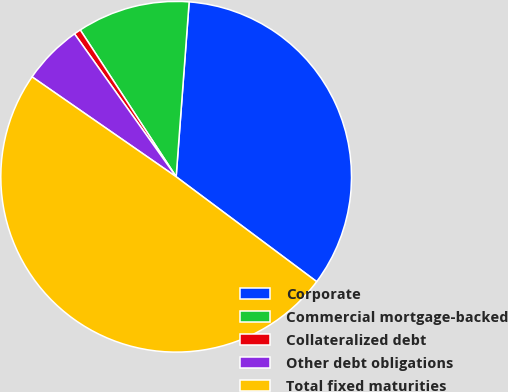Convert chart. <chart><loc_0><loc_0><loc_500><loc_500><pie_chart><fcel>Corporate<fcel>Commercial mortgage-backed<fcel>Collateralized debt<fcel>Other debt obligations<fcel>Total fixed maturities<nl><fcel>34.02%<fcel>10.39%<fcel>0.63%<fcel>5.51%<fcel>49.44%<nl></chart> 